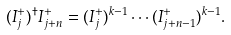Convert formula to latex. <formula><loc_0><loc_0><loc_500><loc_500>( I ^ { + } _ { j } ) ^ { \dagger } I ^ { + } _ { j + n } = ( I ^ { + } _ { j } ) ^ { k - 1 } \cdots ( I ^ { + } _ { j + n - 1 } ) ^ { k - 1 } .</formula> 